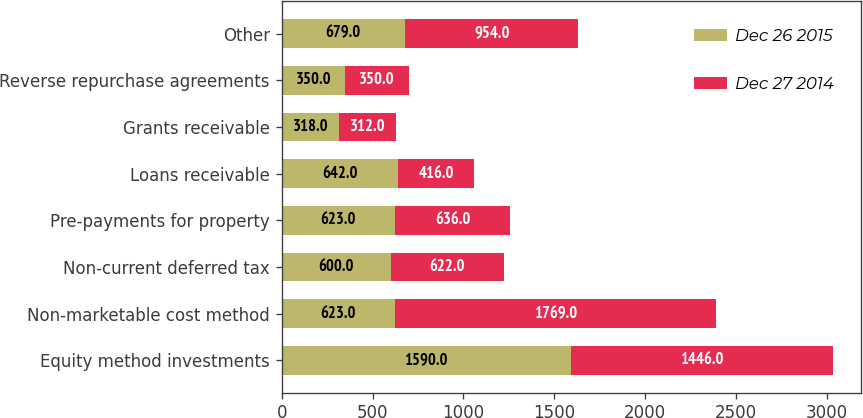Convert chart to OTSL. <chart><loc_0><loc_0><loc_500><loc_500><stacked_bar_chart><ecel><fcel>Equity method investments<fcel>Non-marketable cost method<fcel>Non-current deferred tax<fcel>Pre-payments for property<fcel>Loans receivable<fcel>Grants receivable<fcel>Reverse repurchase agreements<fcel>Other<nl><fcel>Dec 26 2015<fcel>1590<fcel>623<fcel>600<fcel>623<fcel>642<fcel>318<fcel>350<fcel>679<nl><fcel>Dec 27 2014<fcel>1446<fcel>1769<fcel>622<fcel>636<fcel>416<fcel>312<fcel>350<fcel>954<nl></chart> 